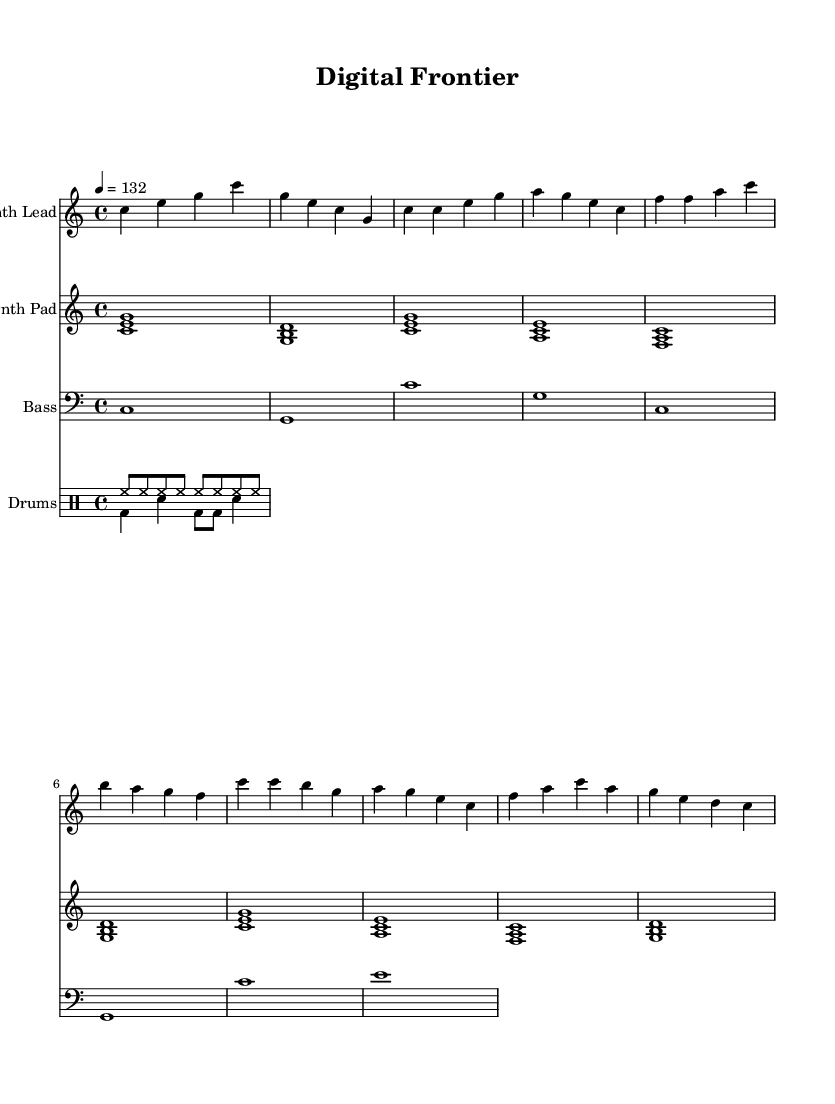What is the key signature of this music? The key signature is C major, which has no sharps or flats.
Answer: C major What is the time signature of the piece? The time signature appears at the beginning of the score and indicates that there are four beats per measure.
Answer: 4/4 What is the tempo marking for this piece? The tempo marking indicates the speed of the piece is 132 beats per minute, labeled at the beginning.
Answer: 132 How many different instrument parts are in the score? The score includes four distinct instrument parts: Synth Lead, Synth Pad, Bass, and Drums.
Answer: 4 Which instrument plays the highest notes in this piece? The Synth Lead part contains the highest pitches as indicated in the notation compared to the other parts.
Answer: Synth Lead What rhythmic pattern is used for the drums? The drums use a combination of hi-hat and bass drum patterns, showing steady eighth notes on the hi-hat and varying notes for the bass drum.
Answer: Eighth notes and varying bass drum What section of the music is the chorus? The chorus is identifiable by a change in melody and rhythm, following a specific pattern starting with the notes c', c, b, and g.
Answer: c' c b g 